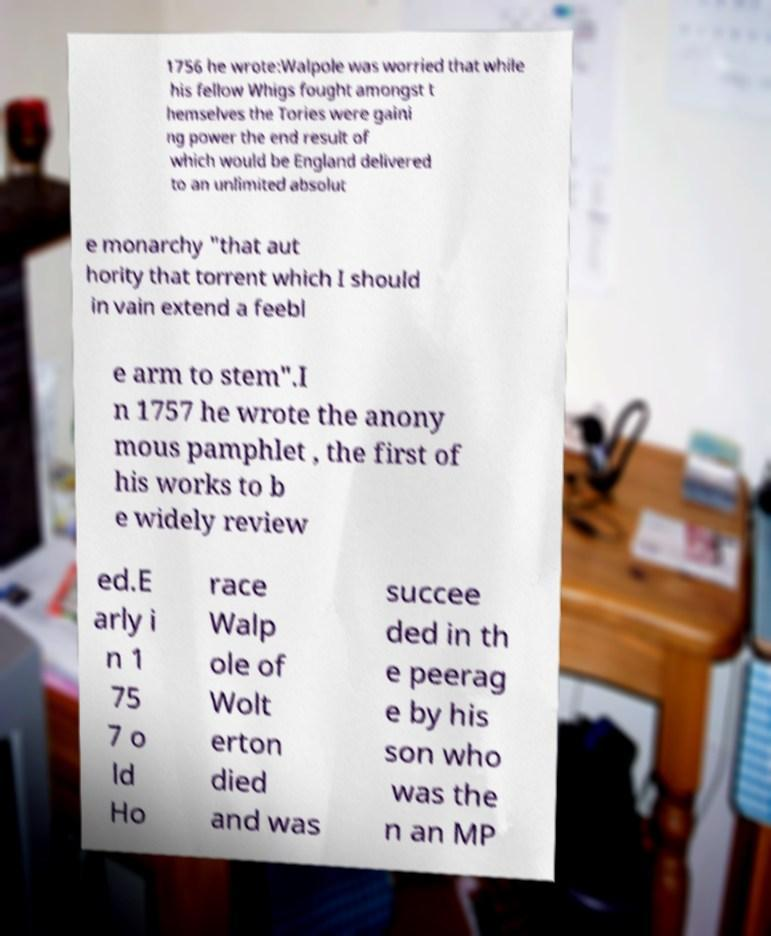Please read and relay the text visible in this image. What does it say? 1756 he wrote:Walpole was worried that while his fellow Whigs fought amongst t hemselves the Tories were gaini ng power the end result of which would be England delivered to an unlimited absolut e monarchy "that aut hority that torrent which I should in vain extend a feebl e arm to stem".I n 1757 he wrote the anony mous pamphlet , the first of his works to b e widely review ed.E arly i n 1 75 7 o ld Ho race Walp ole of Wolt erton died and was succee ded in th e peerag e by his son who was the n an MP 